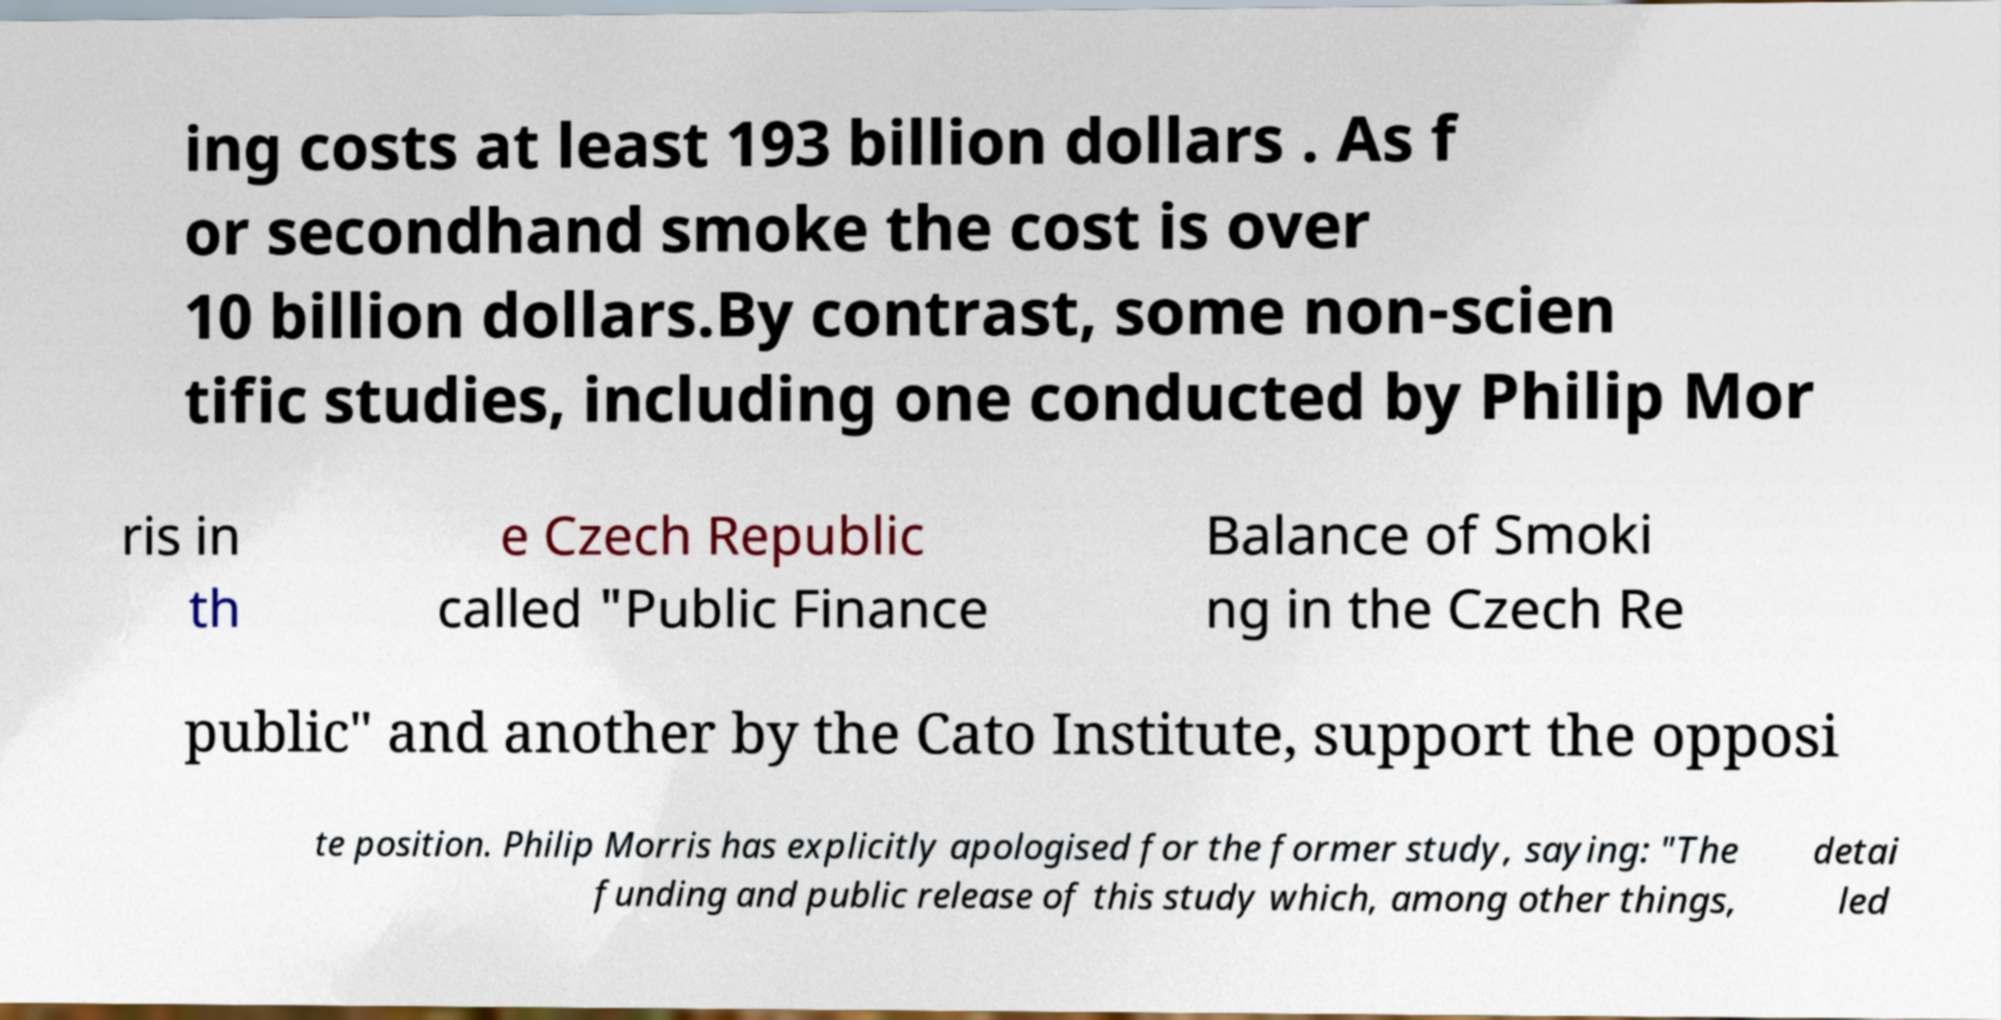For documentation purposes, I need the text within this image transcribed. Could you provide that? ing costs at least 193 billion dollars . As f or secondhand smoke the cost is over 10 billion dollars.By contrast, some non-scien tific studies, including one conducted by Philip Mor ris in th e Czech Republic called "Public Finance Balance of Smoki ng in the Czech Re public" and another by the Cato Institute, support the opposi te position. Philip Morris has explicitly apologised for the former study, saying: "The funding and public release of this study which, among other things, detai led 